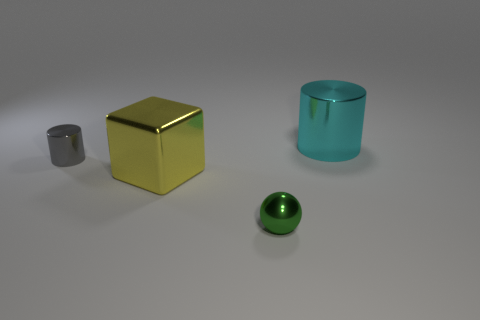Add 4 small gray blocks. How many objects exist? 8 Subtract all blocks. How many objects are left? 3 Add 2 large blue rubber objects. How many large blue rubber objects exist? 2 Subtract 1 cyan cylinders. How many objects are left? 3 Subtract all big cyan metal things. Subtract all gray metallic cylinders. How many objects are left? 2 Add 1 small green shiny spheres. How many small green shiny spheres are left? 2 